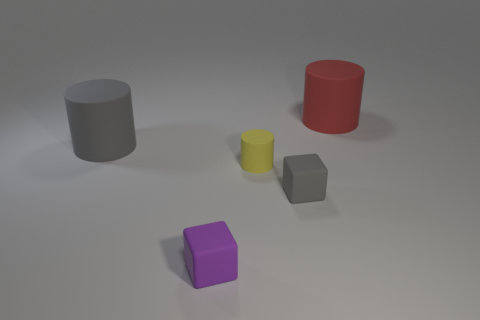Subtract all gray rubber cylinders. How many cylinders are left? 2 Subtract all gray cubes. How many cubes are left? 1 Add 2 tiny brown rubber things. How many objects exist? 7 Subtract 2 cylinders. How many cylinders are left? 1 Subtract 0 purple spheres. How many objects are left? 5 Subtract all cubes. How many objects are left? 3 Subtract all blue blocks. Subtract all green spheres. How many blocks are left? 2 Subtract all tiny purple objects. Subtract all large objects. How many objects are left? 2 Add 5 large red cylinders. How many large red cylinders are left? 6 Add 5 yellow things. How many yellow things exist? 6 